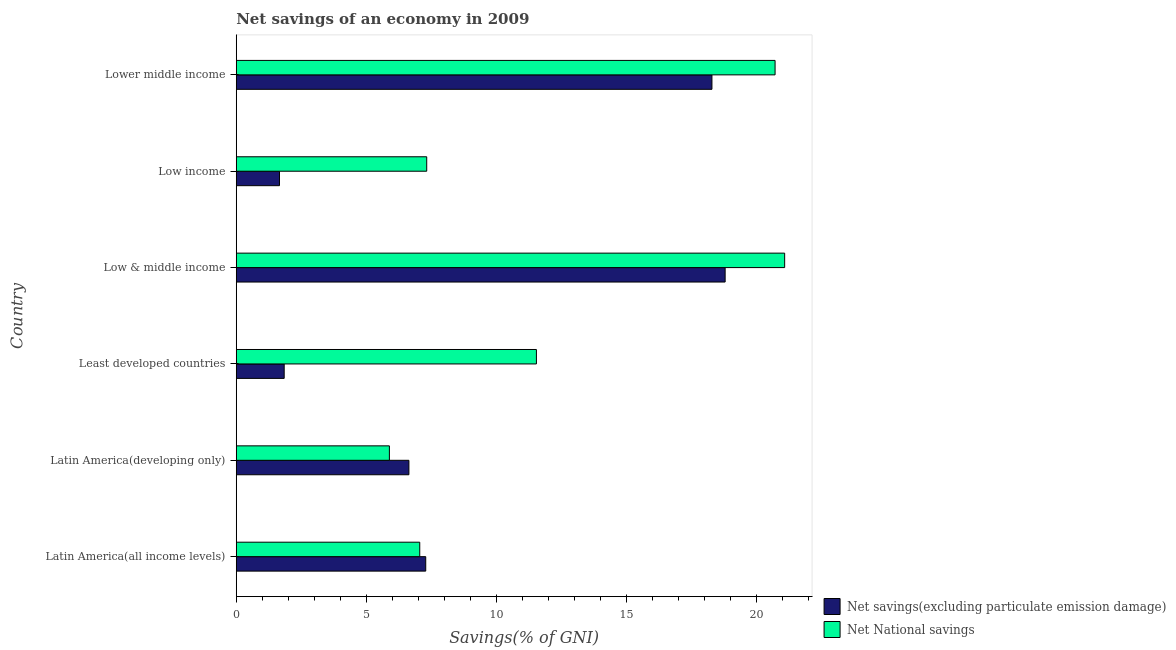How many groups of bars are there?
Your answer should be very brief. 6. Are the number of bars per tick equal to the number of legend labels?
Your answer should be very brief. Yes. Are the number of bars on each tick of the Y-axis equal?
Your answer should be compact. Yes. How many bars are there on the 2nd tick from the top?
Keep it short and to the point. 2. What is the label of the 1st group of bars from the top?
Provide a short and direct response. Lower middle income. What is the net national savings in Latin America(all income levels)?
Your answer should be very brief. 7.06. Across all countries, what is the maximum net national savings?
Your answer should be very brief. 21.09. Across all countries, what is the minimum net savings(excluding particulate emission damage)?
Your answer should be compact. 1.66. In which country was the net national savings maximum?
Provide a short and direct response. Low & middle income. In which country was the net national savings minimum?
Provide a short and direct response. Latin America(developing only). What is the total net national savings in the graph?
Provide a short and direct response. 73.61. What is the difference between the net savings(excluding particulate emission damage) in Low income and that in Lower middle income?
Ensure brevity in your answer.  -16.63. What is the difference between the net savings(excluding particulate emission damage) in Latin America(developing only) and the net national savings in Lower middle income?
Provide a succinct answer. -14.08. What is the average net national savings per country?
Your answer should be very brief. 12.27. What is the ratio of the net national savings in Least developed countries to that in Low income?
Give a very brief answer. 1.58. What is the difference between the highest and the second highest net national savings?
Offer a very short reply. 0.37. Is the sum of the net savings(excluding particulate emission damage) in Latin America(all income levels) and Low income greater than the maximum net national savings across all countries?
Make the answer very short. No. What does the 1st bar from the top in Lower middle income represents?
Provide a short and direct response. Net National savings. What does the 2nd bar from the bottom in Latin America(all income levels) represents?
Offer a terse response. Net National savings. How many bars are there?
Ensure brevity in your answer.  12. Are all the bars in the graph horizontal?
Provide a short and direct response. Yes. How many countries are there in the graph?
Provide a short and direct response. 6. Does the graph contain any zero values?
Your response must be concise. No. Where does the legend appear in the graph?
Ensure brevity in your answer.  Bottom right. What is the title of the graph?
Ensure brevity in your answer.  Net savings of an economy in 2009. What is the label or title of the X-axis?
Keep it short and to the point. Savings(% of GNI). What is the Savings(% of GNI) in Net savings(excluding particulate emission damage) in Latin America(all income levels)?
Provide a succinct answer. 7.29. What is the Savings(% of GNI) of Net National savings in Latin America(all income levels)?
Your answer should be very brief. 7.06. What is the Savings(% of GNI) of Net savings(excluding particulate emission damage) in Latin America(developing only)?
Give a very brief answer. 6.64. What is the Savings(% of GNI) in Net National savings in Latin America(developing only)?
Your answer should be compact. 5.89. What is the Savings(% of GNI) of Net savings(excluding particulate emission damage) in Least developed countries?
Make the answer very short. 1.84. What is the Savings(% of GNI) of Net National savings in Least developed countries?
Your response must be concise. 11.54. What is the Savings(% of GNI) in Net savings(excluding particulate emission damage) in Low & middle income?
Provide a succinct answer. 18.8. What is the Savings(% of GNI) in Net National savings in Low & middle income?
Offer a terse response. 21.09. What is the Savings(% of GNI) in Net savings(excluding particulate emission damage) in Low income?
Keep it short and to the point. 1.66. What is the Savings(% of GNI) in Net National savings in Low income?
Offer a terse response. 7.32. What is the Savings(% of GNI) in Net savings(excluding particulate emission damage) in Lower middle income?
Your answer should be compact. 18.29. What is the Savings(% of GNI) of Net National savings in Lower middle income?
Offer a terse response. 20.72. Across all countries, what is the maximum Savings(% of GNI) of Net savings(excluding particulate emission damage)?
Ensure brevity in your answer.  18.8. Across all countries, what is the maximum Savings(% of GNI) of Net National savings?
Give a very brief answer. 21.09. Across all countries, what is the minimum Savings(% of GNI) in Net savings(excluding particulate emission damage)?
Provide a succinct answer. 1.66. Across all countries, what is the minimum Savings(% of GNI) in Net National savings?
Offer a very short reply. 5.89. What is the total Savings(% of GNI) of Net savings(excluding particulate emission damage) in the graph?
Your response must be concise. 54.52. What is the total Savings(% of GNI) in Net National savings in the graph?
Ensure brevity in your answer.  73.61. What is the difference between the Savings(% of GNI) in Net savings(excluding particulate emission damage) in Latin America(all income levels) and that in Latin America(developing only)?
Keep it short and to the point. 0.65. What is the difference between the Savings(% of GNI) in Net National savings in Latin America(all income levels) and that in Latin America(developing only)?
Your response must be concise. 1.17. What is the difference between the Savings(% of GNI) of Net savings(excluding particulate emission damage) in Latin America(all income levels) and that in Least developed countries?
Offer a very short reply. 5.44. What is the difference between the Savings(% of GNI) of Net National savings in Latin America(all income levels) and that in Least developed countries?
Your answer should be compact. -4.49. What is the difference between the Savings(% of GNI) of Net savings(excluding particulate emission damage) in Latin America(all income levels) and that in Low & middle income?
Give a very brief answer. -11.51. What is the difference between the Savings(% of GNI) in Net National savings in Latin America(all income levels) and that in Low & middle income?
Offer a terse response. -14.03. What is the difference between the Savings(% of GNI) of Net savings(excluding particulate emission damage) in Latin America(all income levels) and that in Low income?
Keep it short and to the point. 5.62. What is the difference between the Savings(% of GNI) of Net National savings in Latin America(all income levels) and that in Low income?
Provide a succinct answer. -0.27. What is the difference between the Savings(% of GNI) in Net savings(excluding particulate emission damage) in Latin America(all income levels) and that in Lower middle income?
Ensure brevity in your answer.  -11. What is the difference between the Savings(% of GNI) in Net National savings in Latin America(all income levels) and that in Lower middle income?
Your response must be concise. -13.66. What is the difference between the Savings(% of GNI) in Net savings(excluding particulate emission damage) in Latin America(developing only) and that in Least developed countries?
Provide a short and direct response. 4.8. What is the difference between the Savings(% of GNI) of Net National savings in Latin America(developing only) and that in Least developed countries?
Give a very brief answer. -5.65. What is the difference between the Savings(% of GNI) in Net savings(excluding particulate emission damage) in Latin America(developing only) and that in Low & middle income?
Offer a very short reply. -12.16. What is the difference between the Savings(% of GNI) of Net National savings in Latin America(developing only) and that in Low & middle income?
Your response must be concise. -15.2. What is the difference between the Savings(% of GNI) of Net savings(excluding particulate emission damage) in Latin America(developing only) and that in Low income?
Offer a very short reply. 4.98. What is the difference between the Savings(% of GNI) in Net National savings in Latin America(developing only) and that in Low income?
Make the answer very short. -1.44. What is the difference between the Savings(% of GNI) of Net savings(excluding particulate emission damage) in Latin America(developing only) and that in Lower middle income?
Provide a short and direct response. -11.65. What is the difference between the Savings(% of GNI) of Net National savings in Latin America(developing only) and that in Lower middle income?
Make the answer very short. -14.83. What is the difference between the Savings(% of GNI) of Net savings(excluding particulate emission damage) in Least developed countries and that in Low & middle income?
Your answer should be compact. -16.95. What is the difference between the Savings(% of GNI) in Net National savings in Least developed countries and that in Low & middle income?
Keep it short and to the point. -9.54. What is the difference between the Savings(% of GNI) of Net savings(excluding particulate emission damage) in Least developed countries and that in Low income?
Your answer should be very brief. 0.18. What is the difference between the Savings(% of GNI) in Net National savings in Least developed countries and that in Low income?
Your response must be concise. 4.22. What is the difference between the Savings(% of GNI) in Net savings(excluding particulate emission damage) in Least developed countries and that in Lower middle income?
Your answer should be very brief. -16.45. What is the difference between the Savings(% of GNI) in Net National savings in Least developed countries and that in Lower middle income?
Make the answer very short. -9.18. What is the difference between the Savings(% of GNI) in Net savings(excluding particulate emission damage) in Low & middle income and that in Low income?
Your response must be concise. 17.14. What is the difference between the Savings(% of GNI) in Net National savings in Low & middle income and that in Low income?
Your answer should be compact. 13.76. What is the difference between the Savings(% of GNI) of Net savings(excluding particulate emission damage) in Low & middle income and that in Lower middle income?
Your answer should be compact. 0.51. What is the difference between the Savings(% of GNI) in Net National savings in Low & middle income and that in Lower middle income?
Provide a succinct answer. 0.37. What is the difference between the Savings(% of GNI) in Net savings(excluding particulate emission damage) in Low income and that in Lower middle income?
Provide a short and direct response. -16.63. What is the difference between the Savings(% of GNI) in Net National savings in Low income and that in Lower middle income?
Your answer should be compact. -13.39. What is the difference between the Savings(% of GNI) of Net savings(excluding particulate emission damage) in Latin America(all income levels) and the Savings(% of GNI) of Net National savings in Latin America(developing only)?
Keep it short and to the point. 1.4. What is the difference between the Savings(% of GNI) of Net savings(excluding particulate emission damage) in Latin America(all income levels) and the Savings(% of GNI) of Net National savings in Least developed countries?
Your response must be concise. -4.26. What is the difference between the Savings(% of GNI) in Net savings(excluding particulate emission damage) in Latin America(all income levels) and the Savings(% of GNI) in Net National savings in Low & middle income?
Your answer should be very brief. -13.8. What is the difference between the Savings(% of GNI) of Net savings(excluding particulate emission damage) in Latin America(all income levels) and the Savings(% of GNI) of Net National savings in Low income?
Offer a very short reply. -0.04. What is the difference between the Savings(% of GNI) in Net savings(excluding particulate emission damage) in Latin America(all income levels) and the Savings(% of GNI) in Net National savings in Lower middle income?
Offer a very short reply. -13.43. What is the difference between the Savings(% of GNI) of Net savings(excluding particulate emission damage) in Latin America(developing only) and the Savings(% of GNI) of Net National savings in Least developed countries?
Offer a very short reply. -4.9. What is the difference between the Savings(% of GNI) of Net savings(excluding particulate emission damage) in Latin America(developing only) and the Savings(% of GNI) of Net National savings in Low & middle income?
Your answer should be very brief. -14.45. What is the difference between the Savings(% of GNI) in Net savings(excluding particulate emission damage) in Latin America(developing only) and the Savings(% of GNI) in Net National savings in Low income?
Offer a terse response. -0.68. What is the difference between the Savings(% of GNI) of Net savings(excluding particulate emission damage) in Latin America(developing only) and the Savings(% of GNI) of Net National savings in Lower middle income?
Keep it short and to the point. -14.08. What is the difference between the Savings(% of GNI) in Net savings(excluding particulate emission damage) in Least developed countries and the Savings(% of GNI) in Net National savings in Low & middle income?
Provide a succinct answer. -19.24. What is the difference between the Savings(% of GNI) of Net savings(excluding particulate emission damage) in Least developed countries and the Savings(% of GNI) of Net National savings in Low income?
Your answer should be compact. -5.48. What is the difference between the Savings(% of GNI) of Net savings(excluding particulate emission damage) in Least developed countries and the Savings(% of GNI) of Net National savings in Lower middle income?
Make the answer very short. -18.87. What is the difference between the Savings(% of GNI) of Net savings(excluding particulate emission damage) in Low & middle income and the Savings(% of GNI) of Net National savings in Low income?
Your answer should be compact. 11.47. What is the difference between the Savings(% of GNI) in Net savings(excluding particulate emission damage) in Low & middle income and the Savings(% of GNI) in Net National savings in Lower middle income?
Ensure brevity in your answer.  -1.92. What is the difference between the Savings(% of GNI) in Net savings(excluding particulate emission damage) in Low income and the Savings(% of GNI) in Net National savings in Lower middle income?
Your answer should be very brief. -19.06. What is the average Savings(% of GNI) in Net savings(excluding particulate emission damage) per country?
Offer a very short reply. 9.09. What is the average Savings(% of GNI) in Net National savings per country?
Provide a short and direct response. 12.27. What is the difference between the Savings(% of GNI) of Net savings(excluding particulate emission damage) and Savings(% of GNI) of Net National savings in Latin America(all income levels)?
Your answer should be compact. 0.23. What is the difference between the Savings(% of GNI) of Net savings(excluding particulate emission damage) and Savings(% of GNI) of Net National savings in Latin America(developing only)?
Keep it short and to the point. 0.75. What is the difference between the Savings(% of GNI) of Net savings(excluding particulate emission damage) and Savings(% of GNI) of Net National savings in Least developed countries?
Offer a very short reply. -9.7. What is the difference between the Savings(% of GNI) in Net savings(excluding particulate emission damage) and Savings(% of GNI) in Net National savings in Low & middle income?
Give a very brief answer. -2.29. What is the difference between the Savings(% of GNI) in Net savings(excluding particulate emission damage) and Savings(% of GNI) in Net National savings in Low income?
Offer a terse response. -5.66. What is the difference between the Savings(% of GNI) in Net savings(excluding particulate emission damage) and Savings(% of GNI) in Net National savings in Lower middle income?
Provide a short and direct response. -2.43. What is the ratio of the Savings(% of GNI) in Net savings(excluding particulate emission damage) in Latin America(all income levels) to that in Latin America(developing only)?
Provide a succinct answer. 1.1. What is the ratio of the Savings(% of GNI) in Net National savings in Latin America(all income levels) to that in Latin America(developing only)?
Ensure brevity in your answer.  1.2. What is the ratio of the Savings(% of GNI) in Net savings(excluding particulate emission damage) in Latin America(all income levels) to that in Least developed countries?
Your answer should be compact. 3.95. What is the ratio of the Savings(% of GNI) of Net National savings in Latin America(all income levels) to that in Least developed countries?
Your answer should be compact. 0.61. What is the ratio of the Savings(% of GNI) in Net savings(excluding particulate emission damage) in Latin America(all income levels) to that in Low & middle income?
Offer a very short reply. 0.39. What is the ratio of the Savings(% of GNI) in Net National savings in Latin America(all income levels) to that in Low & middle income?
Offer a terse response. 0.33. What is the ratio of the Savings(% of GNI) in Net savings(excluding particulate emission damage) in Latin America(all income levels) to that in Low income?
Keep it short and to the point. 4.38. What is the ratio of the Savings(% of GNI) of Net National savings in Latin America(all income levels) to that in Low income?
Provide a succinct answer. 0.96. What is the ratio of the Savings(% of GNI) in Net savings(excluding particulate emission damage) in Latin America(all income levels) to that in Lower middle income?
Make the answer very short. 0.4. What is the ratio of the Savings(% of GNI) in Net National savings in Latin America(all income levels) to that in Lower middle income?
Keep it short and to the point. 0.34. What is the ratio of the Savings(% of GNI) of Net savings(excluding particulate emission damage) in Latin America(developing only) to that in Least developed countries?
Your answer should be compact. 3.6. What is the ratio of the Savings(% of GNI) of Net National savings in Latin America(developing only) to that in Least developed countries?
Keep it short and to the point. 0.51. What is the ratio of the Savings(% of GNI) of Net savings(excluding particulate emission damage) in Latin America(developing only) to that in Low & middle income?
Your answer should be compact. 0.35. What is the ratio of the Savings(% of GNI) of Net National savings in Latin America(developing only) to that in Low & middle income?
Ensure brevity in your answer.  0.28. What is the ratio of the Savings(% of GNI) in Net savings(excluding particulate emission damage) in Latin America(developing only) to that in Low income?
Your answer should be very brief. 3.99. What is the ratio of the Savings(% of GNI) in Net National savings in Latin America(developing only) to that in Low income?
Give a very brief answer. 0.8. What is the ratio of the Savings(% of GNI) in Net savings(excluding particulate emission damage) in Latin America(developing only) to that in Lower middle income?
Keep it short and to the point. 0.36. What is the ratio of the Savings(% of GNI) of Net National savings in Latin America(developing only) to that in Lower middle income?
Provide a succinct answer. 0.28. What is the ratio of the Savings(% of GNI) of Net savings(excluding particulate emission damage) in Least developed countries to that in Low & middle income?
Provide a succinct answer. 0.1. What is the ratio of the Savings(% of GNI) of Net National savings in Least developed countries to that in Low & middle income?
Ensure brevity in your answer.  0.55. What is the ratio of the Savings(% of GNI) in Net savings(excluding particulate emission damage) in Least developed countries to that in Low income?
Offer a very short reply. 1.11. What is the ratio of the Savings(% of GNI) in Net National savings in Least developed countries to that in Low income?
Make the answer very short. 1.58. What is the ratio of the Savings(% of GNI) of Net savings(excluding particulate emission damage) in Least developed countries to that in Lower middle income?
Ensure brevity in your answer.  0.1. What is the ratio of the Savings(% of GNI) in Net National savings in Least developed countries to that in Lower middle income?
Ensure brevity in your answer.  0.56. What is the ratio of the Savings(% of GNI) in Net savings(excluding particulate emission damage) in Low & middle income to that in Low income?
Your response must be concise. 11.31. What is the ratio of the Savings(% of GNI) of Net National savings in Low & middle income to that in Low income?
Your response must be concise. 2.88. What is the ratio of the Savings(% of GNI) in Net savings(excluding particulate emission damage) in Low & middle income to that in Lower middle income?
Provide a succinct answer. 1.03. What is the ratio of the Savings(% of GNI) in Net National savings in Low & middle income to that in Lower middle income?
Provide a short and direct response. 1.02. What is the ratio of the Savings(% of GNI) in Net savings(excluding particulate emission damage) in Low income to that in Lower middle income?
Your response must be concise. 0.09. What is the ratio of the Savings(% of GNI) of Net National savings in Low income to that in Lower middle income?
Your response must be concise. 0.35. What is the difference between the highest and the second highest Savings(% of GNI) in Net savings(excluding particulate emission damage)?
Provide a short and direct response. 0.51. What is the difference between the highest and the second highest Savings(% of GNI) in Net National savings?
Keep it short and to the point. 0.37. What is the difference between the highest and the lowest Savings(% of GNI) of Net savings(excluding particulate emission damage)?
Offer a very short reply. 17.14. What is the difference between the highest and the lowest Savings(% of GNI) of Net National savings?
Offer a very short reply. 15.2. 